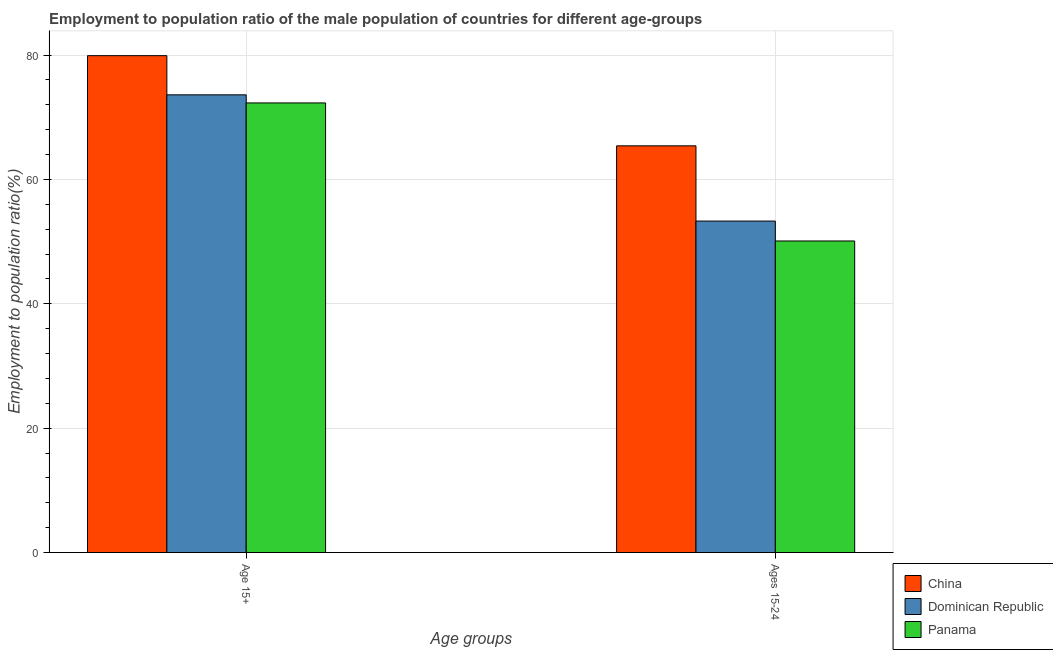How many different coloured bars are there?
Your answer should be compact. 3. Are the number of bars on each tick of the X-axis equal?
Offer a very short reply. Yes. What is the label of the 2nd group of bars from the left?
Make the answer very short. Ages 15-24. What is the employment to population ratio(age 15+) in Panama?
Ensure brevity in your answer.  72.3. Across all countries, what is the maximum employment to population ratio(age 15-24)?
Your response must be concise. 65.4. Across all countries, what is the minimum employment to population ratio(age 15-24)?
Your answer should be compact. 50.1. In which country was the employment to population ratio(age 15+) maximum?
Your answer should be very brief. China. In which country was the employment to population ratio(age 15-24) minimum?
Your response must be concise. Panama. What is the total employment to population ratio(age 15-24) in the graph?
Provide a short and direct response. 168.8. What is the difference between the employment to population ratio(age 15-24) in Dominican Republic and that in China?
Your answer should be very brief. -12.1. What is the difference between the employment to population ratio(age 15-24) in Panama and the employment to population ratio(age 15+) in China?
Your answer should be compact. -29.8. What is the average employment to population ratio(age 15+) per country?
Ensure brevity in your answer.  75.27. What is the difference between the employment to population ratio(age 15-24) and employment to population ratio(age 15+) in Dominican Republic?
Provide a short and direct response. -20.3. In how many countries, is the employment to population ratio(age 15-24) greater than 64 %?
Give a very brief answer. 1. What is the ratio of the employment to population ratio(age 15+) in China to that in Dominican Republic?
Your response must be concise. 1.09. Is the employment to population ratio(age 15+) in China less than that in Dominican Republic?
Ensure brevity in your answer.  No. In how many countries, is the employment to population ratio(age 15-24) greater than the average employment to population ratio(age 15-24) taken over all countries?
Make the answer very short. 1. What does the 1st bar from the left in Ages 15-24 represents?
Your answer should be compact. China. What does the 2nd bar from the right in Age 15+ represents?
Provide a short and direct response. Dominican Republic. Are the values on the major ticks of Y-axis written in scientific E-notation?
Provide a short and direct response. No. What is the title of the graph?
Offer a terse response. Employment to population ratio of the male population of countries for different age-groups. What is the label or title of the X-axis?
Provide a succinct answer. Age groups. What is the label or title of the Y-axis?
Offer a terse response. Employment to population ratio(%). What is the Employment to population ratio(%) in China in Age 15+?
Keep it short and to the point. 79.9. What is the Employment to population ratio(%) in Dominican Republic in Age 15+?
Keep it short and to the point. 73.6. What is the Employment to population ratio(%) in Panama in Age 15+?
Give a very brief answer. 72.3. What is the Employment to population ratio(%) in China in Ages 15-24?
Offer a very short reply. 65.4. What is the Employment to population ratio(%) of Dominican Republic in Ages 15-24?
Your answer should be very brief. 53.3. What is the Employment to population ratio(%) of Panama in Ages 15-24?
Give a very brief answer. 50.1. Across all Age groups, what is the maximum Employment to population ratio(%) in China?
Make the answer very short. 79.9. Across all Age groups, what is the maximum Employment to population ratio(%) in Dominican Republic?
Your response must be concise. 73.6. Across all Age groups, what is the maximum Employment to population ratio(%) of Panama?
Make the answer very short. 72.3. Across all Age groups, what is the minimum Employment to population ratio(%) in China?
Make the answer very short. 65.4. Across all Age groups, what is the minimum Employment to population ratio(%) in Dominican Republic?
Give a very brief answer. 53.3. Across all Age groups, what is the minimum Employment to population ratio(%) in Panama?
Your answer should be compact. 50.1. What is the total Employment to population ratio(%) of China in the graph?
Your answer should be compact. 145.3. What is the total Employment to population ratio(%) of Dominican Republic in the graph?
Your answer should be compact. 126.9. What is the total Employment to population ratio(%) of Panama in the graph?
Make the answer very short. 122.4. What is the difference between the Employment to population ratio(%) of Dominican Republic in Age 15+ and that in Ages 15-24?
Your answer should be compact. 20.3. What is the difference between the Employment to population ratio(%) in Panama in Age 15+ and that in Ages 15-24?
Make the answer very short. 22.2. What is the difference between the Employment to population ratio(%) in China in Age 15+ and the Employment to population ratio(%) in Dominican Republic in Ages 15-24?
Provide a short and direct response. 26.6. What is the difference between the Employment to population ratio(%) of China in Age 15+ and the Employment to population ratio(%) of Panama in Ages 15-24?
Provide a succinct answer. 29.8. What is the difference between the Employment to population ratio(%) of Dominican Republic in Age 15+ and the Employment to population ratio(%) of Panama in Ages 15-24?
Give a very brief answer. 23.5. What is the average Employment to population ratio(%) of China per Age groups?
Ensure brevity in your answer.  72.65. What is the average Employment to population ratio(%) in Dominican Republic per Age groups?
Ensure brevity in your answer.  63.45. What is the average Employment to population ratio(%) in Panama per Age groups?
Make the answer very short. 61.2. What is the difference between the Employment to population ratio(%) in China and Employment to population ratio(%) in Panama in Age 15+?
Give a very brief answer. 7.6. What is the difference between the Employment to population ratio(%) of Dominican Republic and Employment to population ratio(%) of Panama in Age 15+?
Your answer should be very brief. 1.3. What is the difference between the Employment to population ratio(%) of China and Employment to population ratio(%) of Panama in Ages 15-24?
Offer a terse response. 15.3. What is the ratio of the Employment to population ratio(%) of China in Age 15+ to that in Ages 15-24?
Provide a short and direct response. 1.22. What is the ratio of the Employment to population ratio(%) in Dominican Republic in Age 15+ to that in Ages 15-24?
Offer a very short reply. 1.38. What is the ratio of the Employment to population ratio(%) of Panama in Age 15+ to that in Ages 15-24?
Provide a succinct answer. 1.44. What is the difference between the highest and the second highest Employment to population ratio(%) of China?
Provide a succinct answer. 14.5. What is the difference between the highest and the second highest Employment to population ratio(%) in Dominican Republic?
Provide a short and direct response. 20.3. What is the difference between the highest and the lowest Employment to population ratio(%) of Dominican Republic?
Keep it short and to the point. 20.3. 